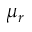Convert formula to latex. <formula><loc_0><loc_0><loc_500><loc_500>\mu _ { r }</formula> 